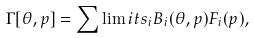Convert formula to latex. <formula><loc_0><loc_0><loc_500><loc_500>\Gamma [ \theta , p ] = \sum \lim i t s _ { i } B _ { i } ( \theta , p ) F _ { i } ( p ) ,</formula> 